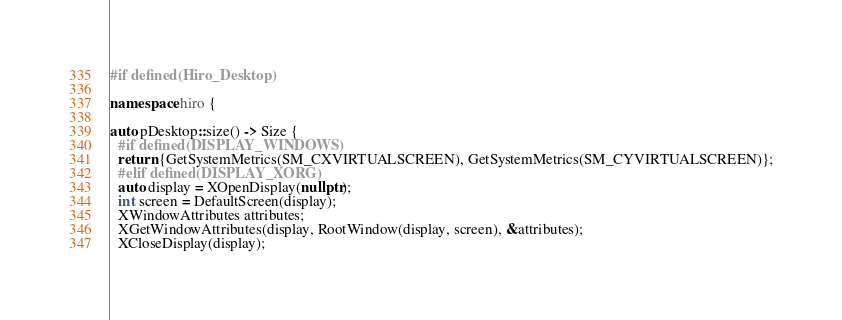<code> <loc_0><loc_0><loc_500><loc_500><_C++_>#if defined(Hiro_Desktop)

namespace hiro {

auto pDesktop::size() -> Size {
  #if defined(DISPLAY_WINDOWS)
  return {GetSystemMetrics(SM_CXVIRTUALSCREEN), GetSystemMetrics(SM_CYVIRTUALSCREEN)};
  #elif defined(DISPLAY_XORG)
  auto display = XOpenDisplay(nullptr);
  int screen = DefaultScreen(display);
  XWindowAttributes attributes;
  XGetWindowAttributes(display, RootWindow(display, screen), &attributes);
  XCloseDisplay(display);</code> 